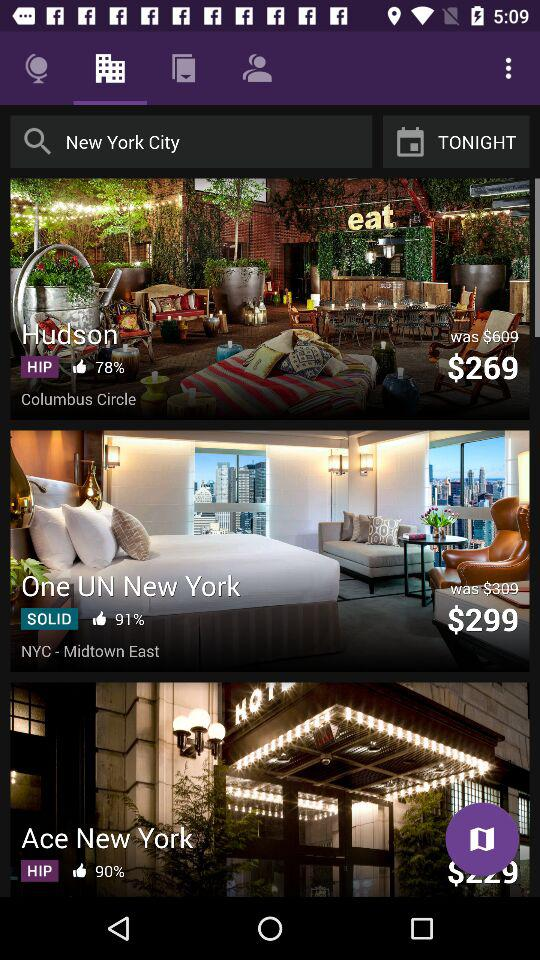What is the current price of "Hudson" hotel? The current price is $269. 